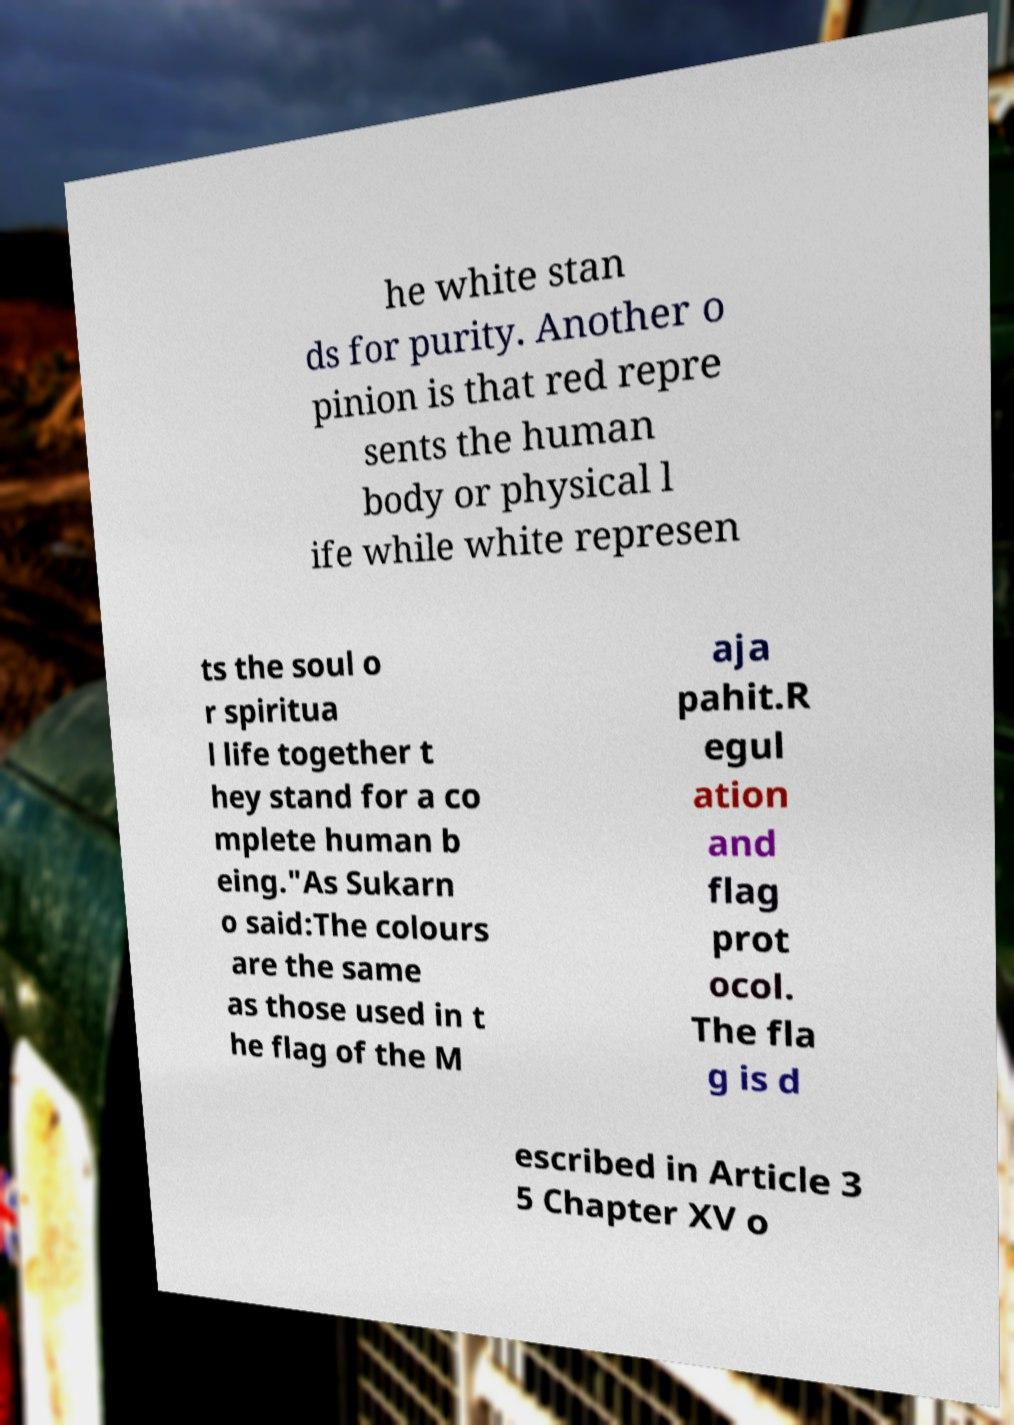Could you assist in decoding the text presented in this image and type it out clearly? he white stan ds for purity. Another o pinion is that red repre sents the human body or physical l ife while white represen ts the soul o r spiritua l life together t hey stand for a co mplete human b eing."As Sukarn o said:The colours are the same as those used in t he flag of the M aja pahit.R egul ation and flag prot ocol. The fla g is d escribed in Article 3 5 Chapter XV o 